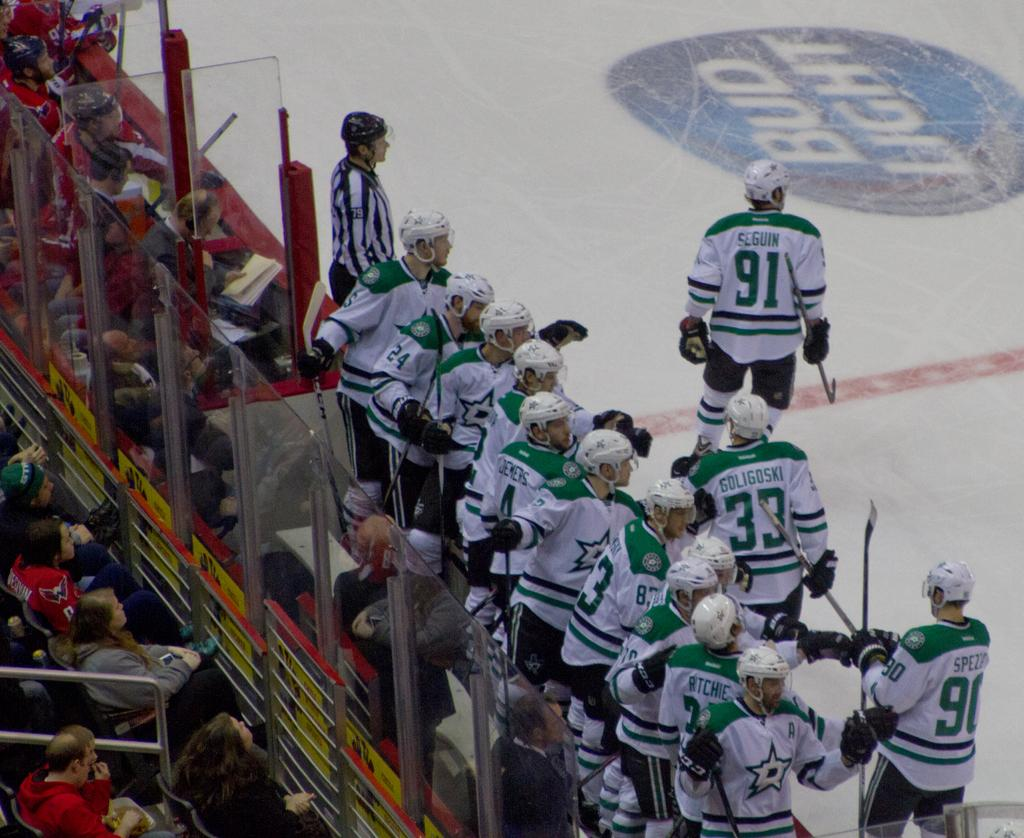<image>
Describe the image concisely. Hockey team celebrating a goal sponsored by Bud Light. 